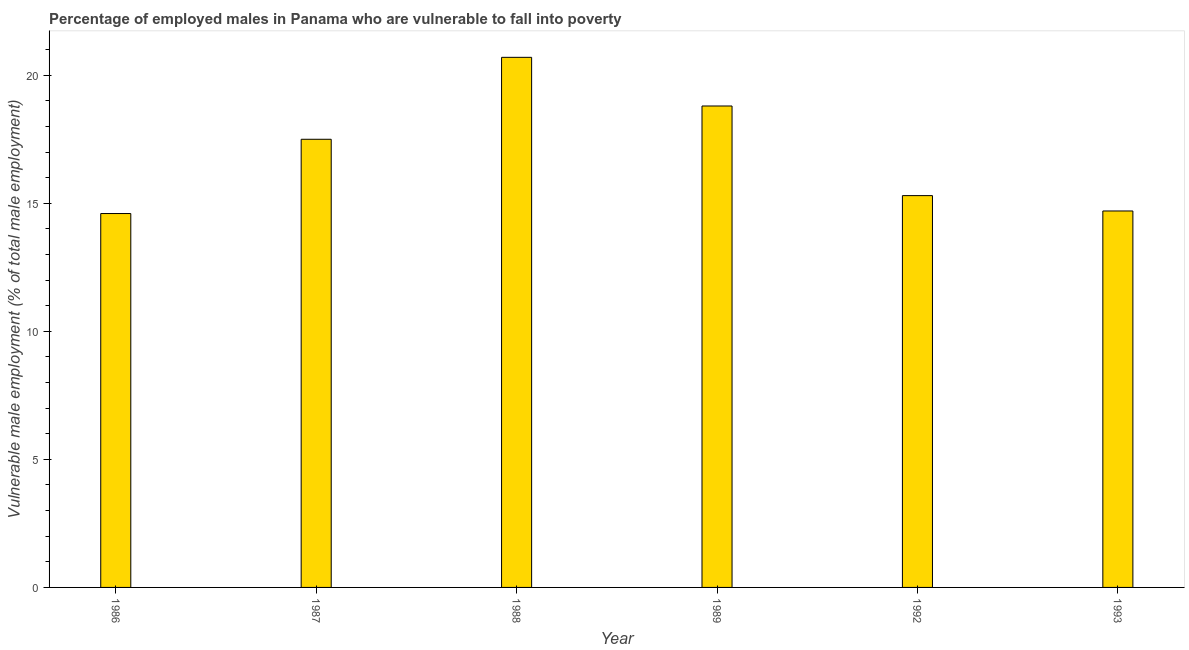What is the title of the graph?
Make the answer very short. Percentage of employed males in Panama who are vulnerable to fall into poverty. What is the label or title of the X-axis?
Ensure brevity in your answer.  Year. What is the label or title of the Y-axis?
Your answer should be very brief. Vulnerable male employment (% of total male employment). What is the percentage of employed males who are vulnerable to fall into poverty in 1993?
Your answer should be compact. 14.7. Across all years, what is the maximum percentage of employed males who are vulnerable to fall into poverty?
Provide a short and direct response. 20.7. Across all years, what is the minimum percentage of employed males who are vulnerable to fall into poverty?
Your response must be concise. 14.6. What is the sum of the percentage of employed males who are vulnerable to fall into poverty?
Give a very brief answer. 101.6. What is the average percentage of employed males who are vulnerable to fall into poverty per year?
Your answer should be very brief. 16.93. What is the median percentage of employed males who are vulnerable to fall into poverty?
Your answer should be compact. 16.4. In how many years, is the percentage of employed males who are vulnerable to fall into poverty greater than 14 %?
Give a very brief answer. 6. Do a majority of the years between 1993 and 1989 (inclusive) have percentage of employed males who are vulnerable to fall into poverty greater than 7 %?
Offer a very short reply. Yes. What is the ratio of the percentage of employed males who are vulnerable to fall into poverty in 1988 to that in 1992?
Offer a terse response. 1.35. Is the percentage of employed males who are vulnerable to fall into poverty in 1988 less than that in 1993?
Give a very brief answer. No. Is the difference between the percentage of employed males who are vulnerable to fall into poverty in 1986 and 1987 greater than the difference between any two years?
Ensure brevity in your answer.  No. What is the difference between the highest and the second highest percentage of employed males who are vulnerable to fall into poverty?
Offer a very short reply. 1.9. Is the sum of the percentage of employed males who are vulnerable to fall into poverty in 1986 and 1993 greater than the maximum percentage of employed males who are vulnerable to fall into poverty across all years?
Give a very brief answer. Yes. What is the difference between the highest and the lowest percentage of employed males who are vulnerable to fall into poverty?
Provide a succinct answer. 6.1. How many years are there in the graph?
Offer a very short reply. 6. Are the values on the major ticks of Y-axis written in scientific E-notation?
Provide a succinct answer. No. What is the Vulnerable male employment (% of total male employment) of 1986?
Give a very brief answer. 14.6. What is the Vulnerable male employment (% of total male employment) in 1988?
Ensure brevity in your answer.  20.7. What is the Vulnerable male employment (% of total male employment) in 1989?
Provide a succinct answer. 18.8. What is the Vulnerable male employment (% of total male employment) of 1992?
Offer a very short reply. 15.3. What is the Vulnerable male employment (% of total male employment) of 1993?
Ensure brevity in your answer.  14.7. What is the difference between the Vulnerable male employment (% of total male employment) in 1986 and 1989?
Provide a short and direct response. -4.2. What is the difference between the Vulnerable male employment (% of total male employment) in 1986 and 1993?
Offer a very short reply. -0.1. What is the difference between the Vulnerable male employment (% of total male employment) in 1987 and 1992?
Your answer should be very brief. 2.2. What is the difference between the Vulnerable male employment (% of total male employment) in 1987 and 1993?
Provide a succinct answer. 2.8. What is the difference between the Vulnerable male employment (% of total male employment) in 1988 and 1993?
Your response must be concise. 6. What is the difference between the Vulnerable male employment (% of total male employment) in 1989 and 1992?
Keep it short and to the point. 3.5. What is the difference between the Vulnerable male employment (% of total male employment) in 1992 and 1993?
Your answer should be compact. 0.6. What is the ratio of the Vulnerable male employment (% of total male employment) in 1986 to that in 1987?
Provide a short and direct response. 0.83. What is the ratio of the Vulnerable male employment (% of total male employment) in 1986 to that in 1988?
Provide a succinct answer. 0.7. What is the ratio of the Vulnerable male employment (% of total male employment) in 1986 to that in 1989?
Give a very brief answer. 0.78. What is the ratio of the Vulnerable male employment (% of total male employment) in 1986 to that in 1992?
Offer a very short reply. 0.95. What is the ratio of the Vulnerable male employment (% of total male employment) in 1986 to that in 1993?
Your answer should be very brief. 0.99. What is the ratio of the Vulnerable male employment (% of total male employment) in 1987 to that in 1988?
Ensure brevity in your answer.  0.84. What is the ratio of the Vulnerable male employment (% of total male employment) in 1987 to that in 1989?
Your response must be concise. 0.93. What is the ratio of the Vulnerable male employment (% of total male employment) in 1987 to that in 1992?
Your response must be concise. 1.14. What is the ratio of the Vulnerable male employment (% of total male employment) in 1987 to that in 1993?
Offer a very short reply. 1.19. What is the ratio of the Vulnerable male employment (% of total male employment) in 1988 to that in 1989?
Offer a very short reply. 1.1. What is the ratio of the Vulnerable male employment (% of total male employment) in 1988 to that in 1992?
Your response must be concise. 1.35. What is the ratio of the Vulnerable male employment (% of total male employment) in 1988 to that in 1993?
Give a very brief answer. 1.41. What is the ratio of the Vulnerable male employment (% of total male employment) in 1989 to that in 1992?
Offer a very short reply. 1.23. What is the ratio of the Vulnerable male employment (% of total male employment) in 1989 to that in 1993?
Your response must be concise. 1.28. What is the ratio of the Vulnerable male employment (% of total male employment) in 1992 to that in 1993?
Your answer should be compact. 1.04. 